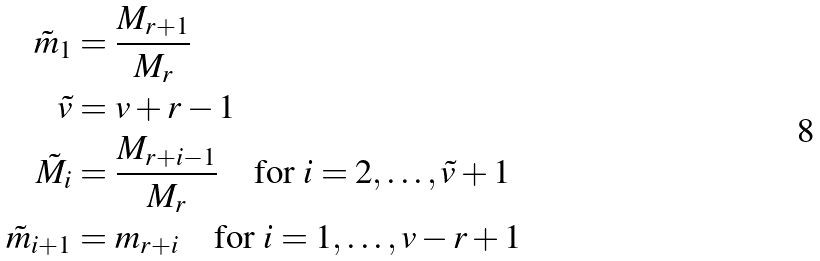<formula> <loc_0><loc_0><loc_500><loc_500>\tilde { m } _ { 1 } & = \frac { M _ { r + 1 } } { M _ { r } } \\ \tilde { v } & = v + r - 1 \\ \tilde { M } _ { i } & = \frac { M _ { r + i - 1 } } { M _ { r } } \quad \text {for} \ i = 2 , \dots , \tilde { v } + 1 \\ \tilde { m } _ { i + 1 } & = m _ { r + i } \quad \text {for} \ i = 1 , \dots , v - r + 1</formula> 